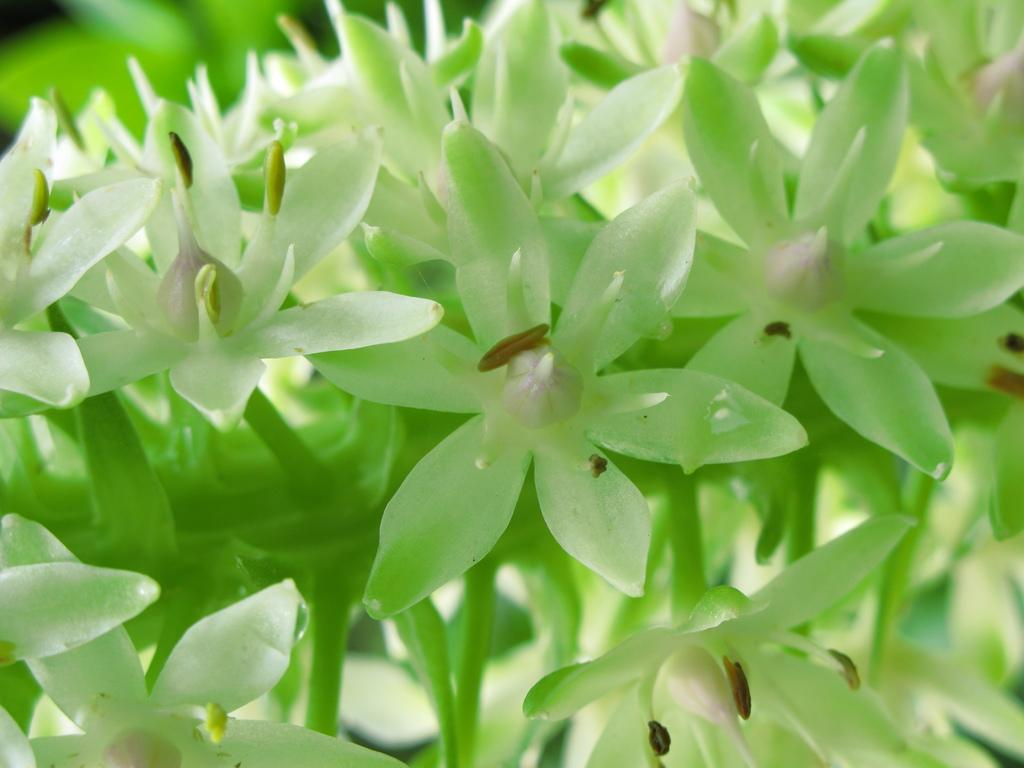What type of living organisms can be seen in the image? Plants can be seen in the image. What color are the flowers on the plants? The flowers on the plants are white in color. What type of reading material is visible in the image? There is no reading material present in the image. What type of trousers are the plants wearing in the image? Plants do not wear trousers, as they are living organisms and not human beings. 